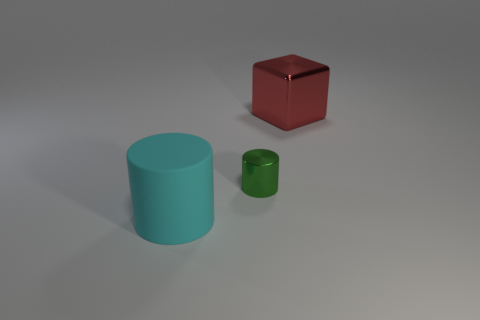Is there anything else that has the same size as the green cylinder?
Give a very brief answer. No. Are there the same number of cyan objects on the right side of the tiny cylinder and small metal things?
Keep it short and to the point. No. What number of things are both to the left of the big red shiny block and to the right of the large cyan rubber object?
Your answer should be very brief. 1. What is the size of the block that is made of the same material as the tiny thing?
Ensure brevity in your answer.  Large. What number of other objects are the same shape as the green shiny object?
Provide a succinct answer. 1. Is the number of cubes that are behind the cyan matte thing greater than the number of purple matte balls?
Your answer should be very brief. Yes. Does the rubber cylinder have the same size as the metal cube?
Make the answer very short. Yes. How many shiny objects are to the left of the big red thing?
Offer a terse response. 1. Is the number of small metallic cylinders that are behind the cube the same as the number of tiny metal objects that are in front of the rubber cylinder?
Offer a terse response. Yes. There is a big object in front of the large red shiny object; does it have the same shape as the tiny green metal object?
Give a very brief answer. Yes. 